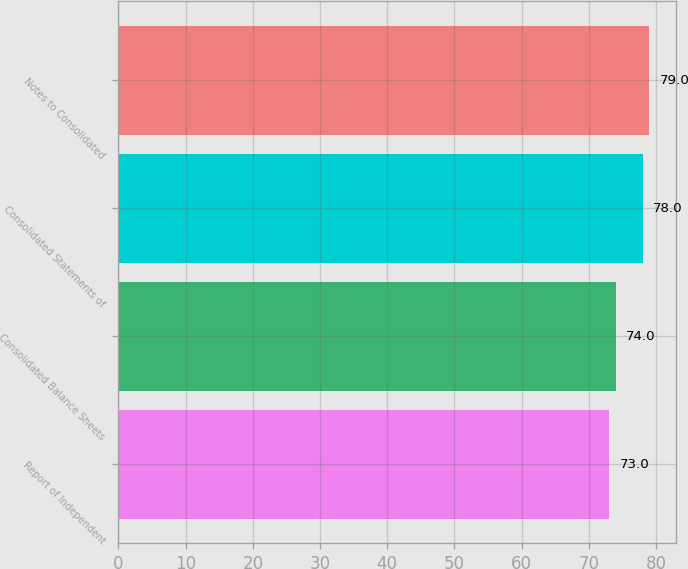Convert chart. <chart><loc_0><loc_0><loc_500><loc_500><bar_chart><fcel>Report of Independent<fcel>Consolidated Balance Sheets<fcel>Consolidated Statements of<fcel>Notes to Consolidated<nl><fcel>73<fcel>74<fcel>78<fcel>79<nl></chart> 